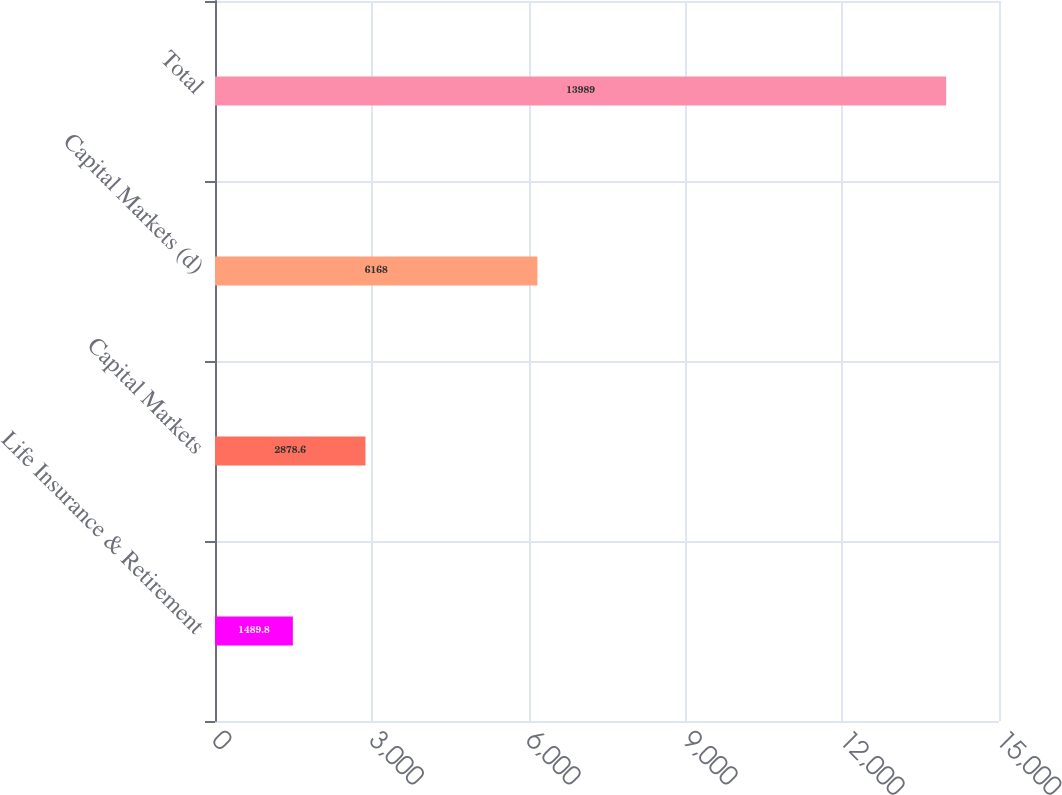<chart> <loc_0><loc_0><loc_500><loc_500><bar_chart><fcel>Life Insurance & Retirement<fcel>Capital Markets<fcel>Capital Markets (d)<fcel>Total<nl><fcel>1489.8<fcel>2878.6<fcel>6168<fcel>13989<nl></chart> 